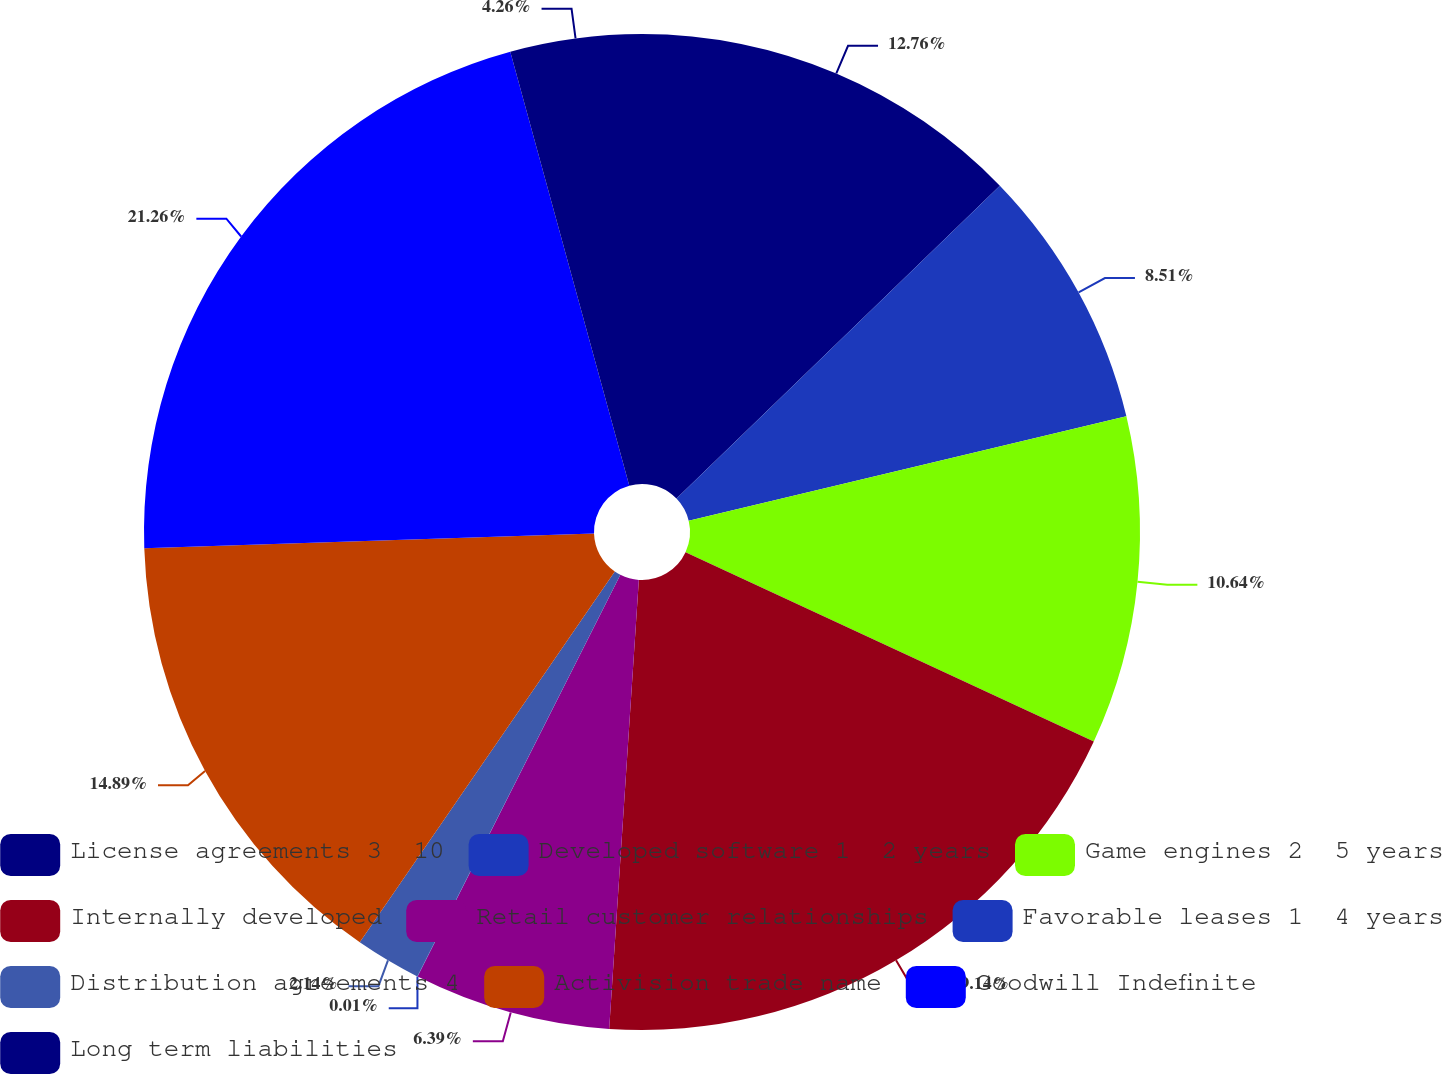Convert chart to OTSL. <chart><loc_0><loc_0><loc_500><loc_500><pie_chart><fcel>License agreements 3 ­ 10<fcel>Developed software 1 ­ 2 years<fcel>Game engines 2 ­ 5 years<fcel>Internally developed<fcel>Retail customer relationships<fcel>Favorable leases 1 ­ 4 years<fcel>Distribution agreements 4<fcel>Activision trade name<fcel>Goodwill Indefinite<fcel>Long term liabilities<nl><fcel>12.76%<fcel>8.51%<fcel>10.64%<fcel>19.14%<fcel>6.39%<fcel>0.01%<fcel>2.14%<fcel>14.89%<fcel>21.26%<fcel>4.26%<nl></chart> 